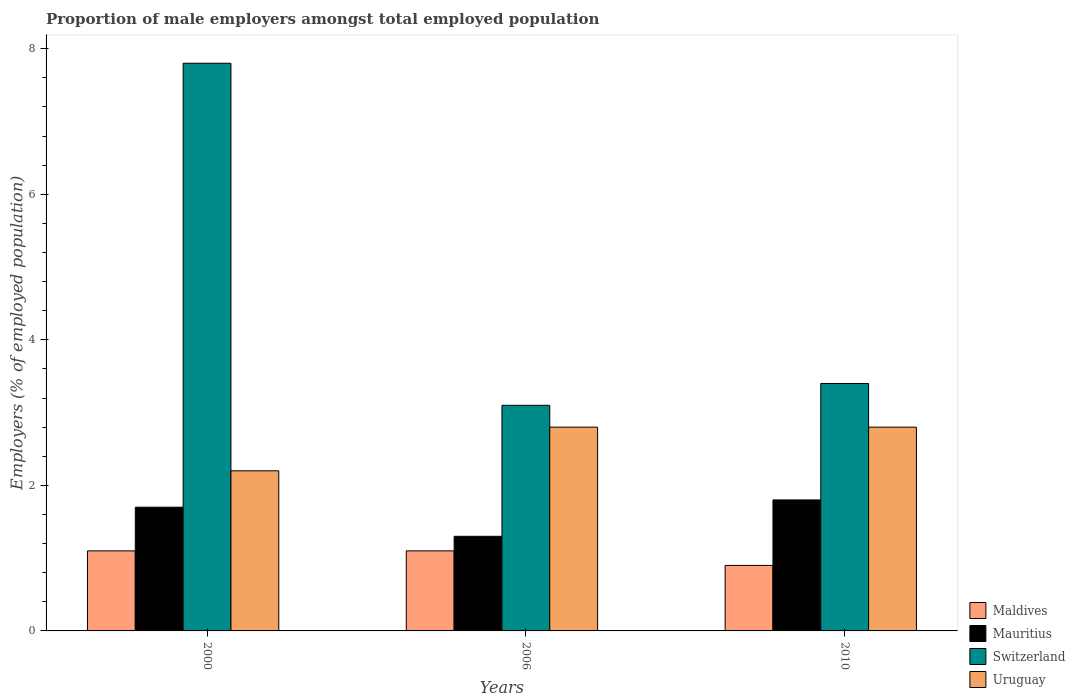How many different coloured bars are there?
Ensure brevity in your answer.  4. Are the number of bars per tick equal to the number of legend labels?
Provide a short and direct response. Yes. Are the number of bars on each tick of the X-axis equal?
Your answer should be very brief. Yes. How many bars are there on the 3rd tick from the right?
Offer a very short reply. 4. What is the label of the 1st group of bars from the left?
Give a very brief answer. 2000. What is the proportion of male employers in Mauritius in 2006?
Make the answer very short. 1.3. Across all years, what is the maximum proportion of male employers in Uruguay?
Give a very brief answer. 2.8. Across all years, what is the minimum proportion of male employers in Maldives?
Keep it short and to the point. 0.9. What is the total proportion of male employers in Uruguay in the graph?
Your answer should be very brief. 7.8. What is the difference between the proportion of male employers in Switzerland in 2000 and that in 2010?
Your answer should be compact. 4.4. What is the difference between the proportion of male employers in Maldives in 2000 and the proportion of male employers in Mauritius in 2010?
Offer a very short reply. -0.7. What is the average proportion of male employers in Uruguay per year?
Give a very brief answer. 2.6. In the year 2010, what is the difference between the proportion of male employers in Mauritius and proportion of male employers in Uruguay?
Your answer should be very brief. -1. In how many years, is the proportion of male employers in Mauritius greater than 2.4 %?
Ensure brevity in your answer.  0. What is the ratio of the proportion of male employers in Switzerland in 2000 to that in 2010?
Your answer should be very brief. 2.29. Is the difference between the proportion of male employers in Mauritius in 2000 and 2010 greater than the difference between the proportion of male employers in Uruguay in 2000 and 2010?
Your answer should be compact. Yes. What is the difference between the highest and the lowest proportion of male employers in Switzerland?
Keep it short and to the point. 4.7. In how many years, is the proportion of male employers in Uruguay greater than the average proportion of male employers in Uruguay taken over all years?
Offer a very short reply. 2. Is the sum of the proportion of male employers in Mauritius in 2000 and 2006 greater than the maximum proportion of male employers in Switzerland across all years?
Provide a succinct answer. No. Is it the case that in every year, the sum of the proportion of male employers in Maldives and proportion of male employers in Uruguay is greater than the sum of proportion of male employers in Mauritius and proportion of male employers in Switzerland?
Your response must be concise. No. What does the 4th bar from the left in 2000 represents?
Give a very brief answer. Uruguay. What does the 3rd bar from the right in 2010 represents?
Your answer should be compact. Mauritius. How many bars are there?
Give a very brief answer. 12. Are all the bars in the graph horizontal?
Offer a very short reply. No. Are the values on the major ticks of Y-axis written in scientific E-notation?
Offer a very short reply. No. Does the graph contain any zero values?
Provide a succinct answer. No. Does the graph contain grids?
Give a very brief answer. No. Where does the legend appear in the graph?
Keep it short and to the point. Bottom right. What is the title of the graph?
Ensure brevity in your answer.  Proportion of male employers amongst total employed population. What is the label or title of the X-axis?
Provide a short and direct response. Years. What is the label or title of the Y-axis?
Your answer should be compact. Employers (% of employed population). What is the Employers (% of employed population) of Maldives in 2000?
Offer a very short reply. 1.1. What is the Employers (% of employed population) of Mauritius in 2000?
Offer a very short reply. 1.7. What is the Employers (% of employed population) of Switzerland in 2000?
Provide a succinct answer. 7.8. What is the Employers (% of employed population) in Uruguay in 2000?
Keep it short and to the point. 2.2. What is the Employers (% of employed population) in Maldives in 2006?
Offer a very short reply. 1.1. What is the Employers (% of employed population) in Mauritius in 2006?
Your answer should be compact. 1.3. What is the Employers (% of employed population) in Switzerland in 2006?
Keep it short and to the point. 3.1. What is the Employers (% of employed population) of Uruguay in 2006?
Provide a succinct answer. 2.8. What is the Employers (% of employed population) of Maldives in 2010?
Offer a terse response. 0.9. What is the Employers (% of employed population) in Mauritius in 2010?
Keep it short and to the point. 1.8. What is the Employers (% of employed population) in Switzerland in 2010?
Keep it short and to the point. 3.4. What is the Employers (% of employed population) in Uruguay in 2010?
Provide a short and direct response. 2.8. Across all years, what is the maximum Employers (% of employed population) in Maldives?
Give a very brief answer. 1.1. Across all years, what is the maximum Employers (% of employed population) of Mauritius?
Offer a very short reply. 1.8. Across all years, what is the maximum Employers (% of employed population) of Switzerland?
Make the answer very short. 7.8. Across all years, what is the maximum Employers (% of employed population) in Uruguay?
Your answer should be very brief. 2.8. Across all years, what is the minimum Employers (% of employed population) of Maldives?
Offer a very short reply. 0.9. Across all years, what is the minimum Employers (% of employed population) of Mauritius?
Offer a terse response. 1.3. Across all years, what is the minimum Employers (% of employed population) in Switzerland?
Provide a succinct answer. 3.1. Across all years, what is the minimum Employers (% of employed population) of Uruguay?
Ensure brevity in your answer.  2.2. What is the total Employers (% of employed population) in Mauritius in the graph?
Your response must be concise. 4.8. What is the total Employers (% of employed population) of Uruguay in the graph?
Keep it short and to the point. 7.8. What is the difference between the Employers (% of employed population) of Mauritius in 2000 and that in 2006?
Give a very brief answer. 0.4. What is the difference between the Employers (% of employed population) in Switzerland in 2000 and that in 2006?
Make the answer very short. 4.7. What is the difference between the Employers (% of employed population) of Uruguay in 2000 and that in 2006?
Your answer should be compact. -0.6. What is the difference between the Employers (% of employed population) in Mauritius in 2000 and that in 2010?
Give a very brief answer. -0.1. What is the difference between the Employers (% of employed population) of Switzerland in 2000 and that in 2010?
Provide a succinct answer. 4.4. What is the difference between the Employers (% of employed population) of Uruguay in 2000 and that in 2010?
Offer a very short reply. -0.6. What is the difference between the Employers (% of employed population) of Maldives in 2006 and that in 2010?
Your answer should be very brief. 0.2. What is the difference between the Employers (% of employed population) in Mauritius in 2006 and that in 2010?
Make the answer very short. -0.5. What is the difference between the Employers (% of employed population) of Maldives in 2000 and the Employers (% of employed population) of Switzerland in 2006?
Give a very brief answer. -2. What is the difference between the Employers (% of employed population) in Maldives in 2000 and the Employers (% of employed population) in Uruguay in 2006?
Ensure brevity in your answer.  -1.7. What is the difference between the Employers (% of employed population) in Switzerland in 2000 and the Employers (% of employed population) in Uruguay in 2006?
Offer a terse response. 5. What is the difference between the Employers (% of employed population) in Maldives in 2000 and the Employers (% of employed population) in Switzerland in 2010?
Keep it short and to the point. -2.3. What is the difference between the Employers (% of employed population) in Maldives in 2000 and the Employers (% of employed population) in Uruguay in 2010?
Give a very brief answer. -1.7. What is the difference between the Employers (% of employed population) of Switzerland in 2000 and the Employers (% of employed population) of Uruguay in 2010?
Make the answer very short. 5. What is the difference between the Employers (% of employed population) in Maldives in 2006 and the Employers (% of employed population) in Mauritius in 2010?
Provide a succinct answer. -0.7. What is the difference between the Employers (% of employed population) in Maldives in 2006 and the Employers (% of employed population) in Uruguay in 2010?
Give a very brief answer. -1.7. What is the difference between the Employers (% of employed population) of Mauritius in 2006 and the Employers (% of employed population) of Switzerland in 2010?
Your response must be concise. -2.1. What is the difference between the Employers (% of employed population) in Switzerland in 2006 and the Employers (% of employed population) in Uruguay in 2010?
Provide a short and direct response. 0.3. What is the average Employers (% of employed population) in Maldives per year?
Ensure brevity in your answer.  1.03. What is the average Employers (% of employed population) in Mauritius per year?
Offer a very short reply. 1.6. What is the average Employers (% of employed population) of Switzerland per year?
Ensure brevity in your answer.  4.77. What is the average Employers (% of employed population) in Uruguay per year?
Keep it short and to the point. 2.6. In the year 2000, what is the difference between the Employers (% of employed population) in Switzerland and Employers (% of employed population) in Uruguay?
Provide a succinct answer. 5.6. In the year 2006, what is the difference between the Employers (% of employed population) of Maldives and Employers (% of employed population) of Switzerland?
Ensure brevity in your answer.  -2. In the year 2006, what is the difference between the Employers (% of employed population) in Maldives and Employers (% of employed population) in Uruguay?
Provide a short and direct response. -1.7. In the year 2006, what is the difference between the Employers (% of employed population) of Mauritius and Employers (% of employed population) of Uruguay?
Ensure brevity in your answer.  -1.5. In the year 2010, what is the difference between the Employers (% of employed population) of Maldives and Employers (% of employed population) of Mauritius?
Keep it short and to the point. -0.9. In the year 2010, what is the difference between the Employers (% of employed population) in Maldives and Employers (% of employed population) in Uruguay?
Your answer should be very brief. -1.9. In the year 2010, what is the difference between the Employers (% of employed population) in Mauritius and Employers (% of employed population) in Switzerland?
Provide a short and direct response. -1.6. What is the ratio of the Employers (% of employed population) in Mauritius in 2000 to that in 2006?
Provide a short and direct response. 1.31. What is the ratio of the Employers (% of employed population) in Switzerland in 2000 to that in 2006?
Your answer should be very brief. 2.52. What is the ratio of the Employers (% of employed population) of Uruguay in 2000 to that in 2006?
Give a very brief answer. 0.79. What is the ratio of the Employers (% of employed population) of Maldives in 2000 to that in 2010?
Your response must be concise. 1.22. What is the ratio of the Employers (% of employed population) in Switzerland in 2000 to that in 2010?
Keep it short and to the point. 2.29. What is the ratio of the Employers (% of employed population) in Uruguay in 2000 to that in 2010?
Your response must be concise. 0.79. What is the ratio of the Employers (% of employed population) of Maldives in 2006 to that in 2010?
Keep it short and to the point. 1.22. What is the ratio of the Employers (% of employed population) of Mauritius in 2006 to that in 2010?
Keep it short and to the point. 0.72. What is the ratio of the Employers (% of employed population) in Switzerland in 2006 to that in 2010?
Make the answer very short. 0.91. What is the ratio of the Employers (% of employed population) of Uruguay in 2006 to that in 2010?
Provide a short and direct response. 1. What is the difference between the highest and the second highest Employers (% of employed population) of Maldives?
Provide a succinct answer. 0. What is the difference between the highest and the lowest Employers (% of employed population) in Uruguay?
Give a very brief answer. 0.6. 